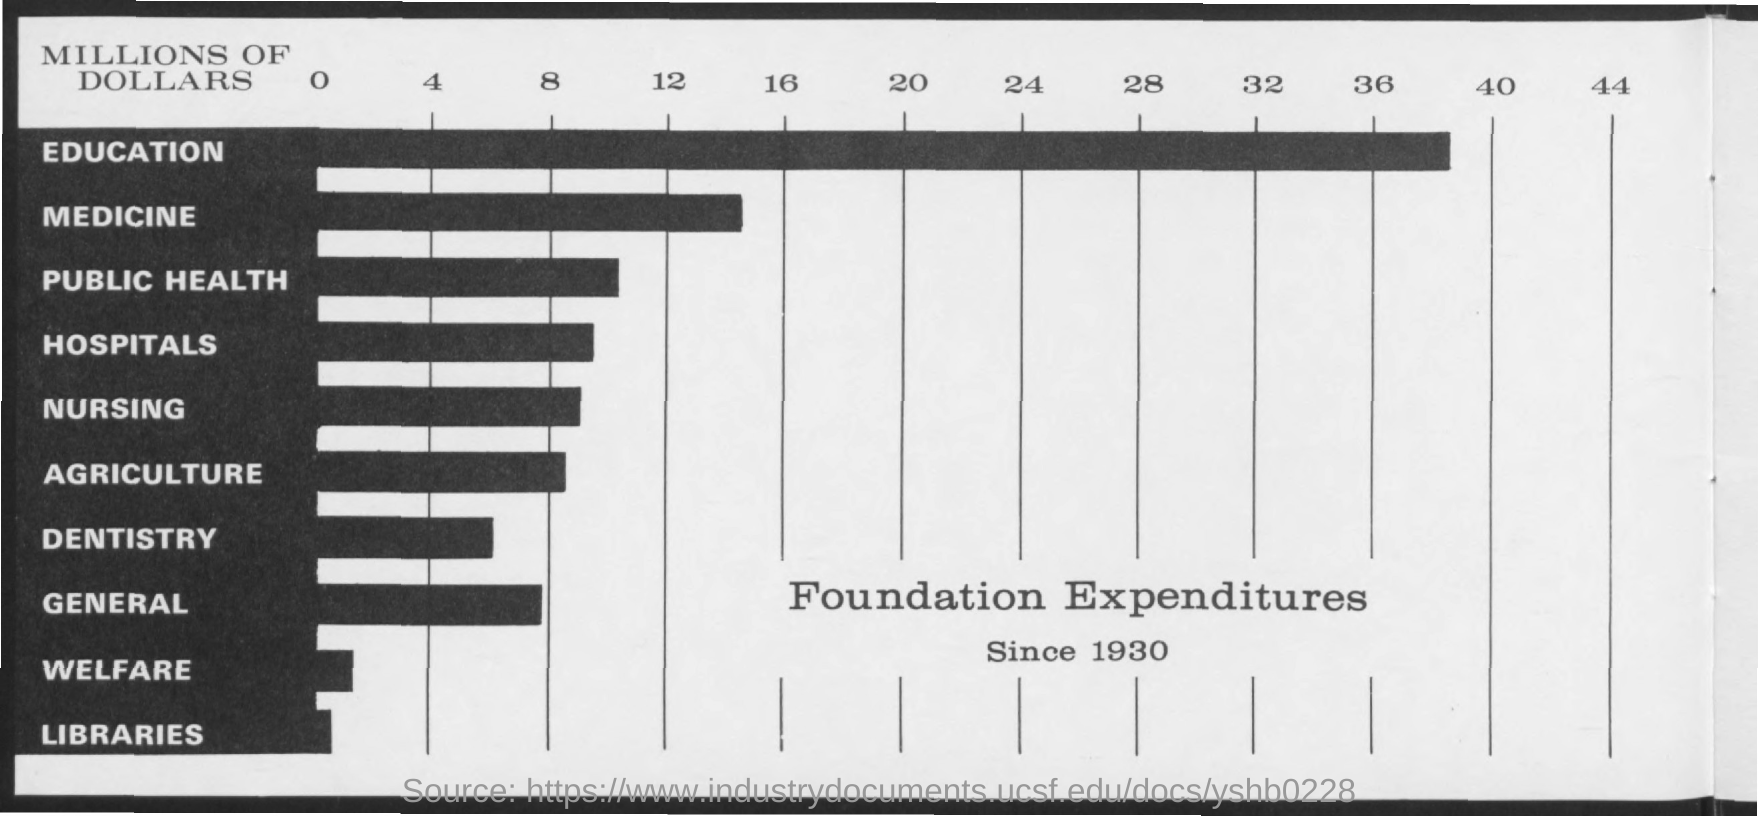On which segment is the expenditure the highest?
Offer a terse response. Education. "Foundation Expenditures Since" which year is mentioned on Y-axis?
Your response must be concise. Since 1930. "Foundation Expenditure" is maximum for which entry on y-axis?
Make the answer very short. Education. "Foundation Expenditure" is minimum for which entry on y-axis?
Offer a very short reply. Libraries. For which entry "Foundation Expenditure" is second highest?
Your answer should be compact. Medicine. What is the maximum value of "MILLIONS OF DOLLARS" mentioned on the graph?
Offer a very short reply. 44. 